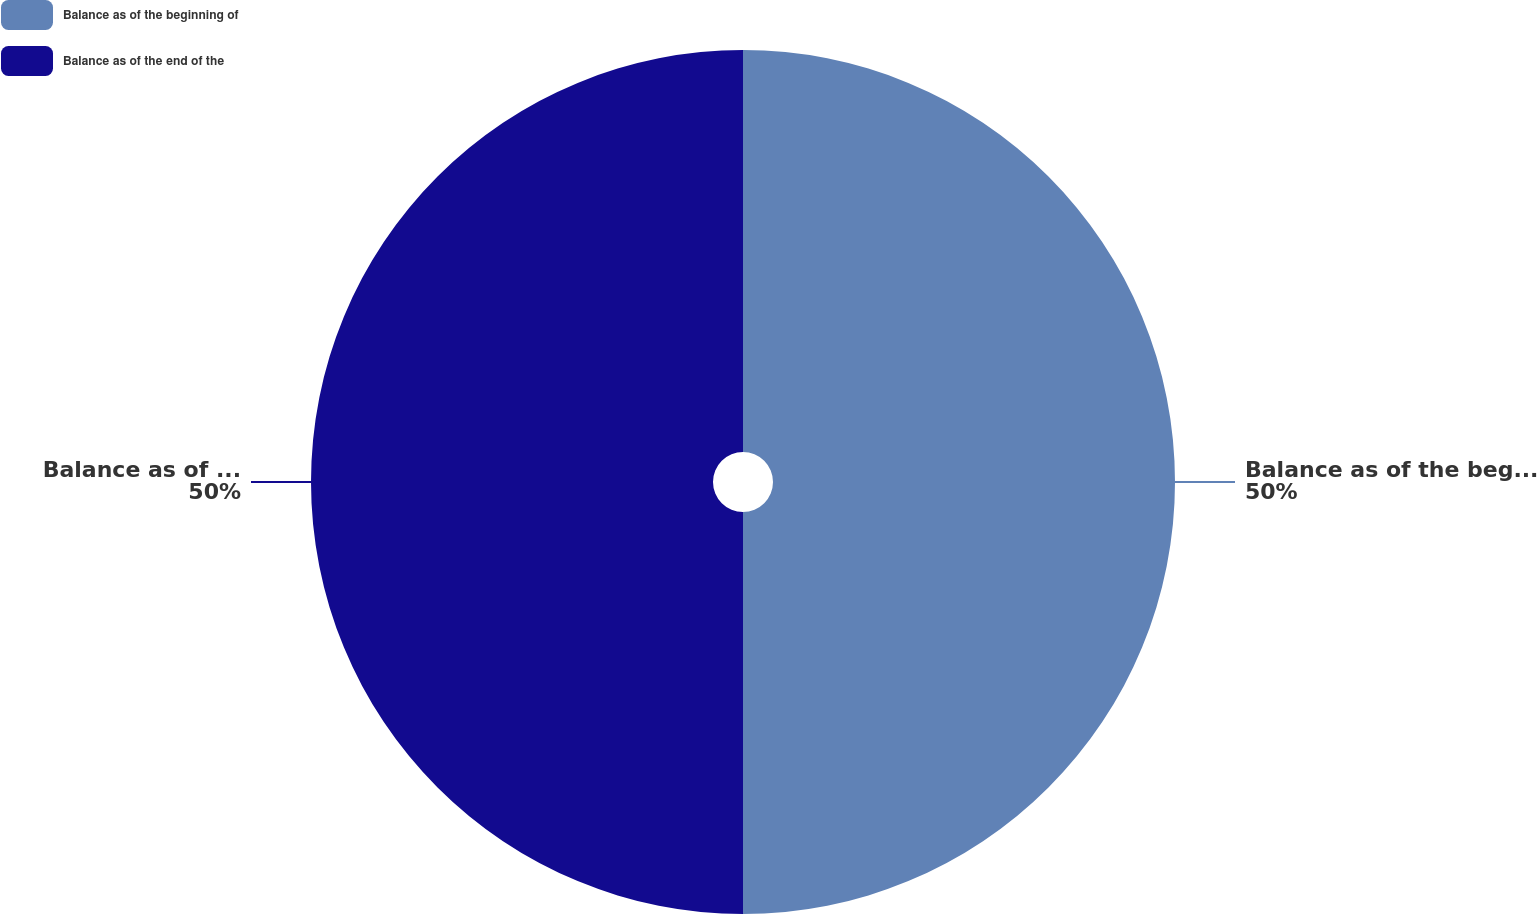Convert chart to OTSL. <chart><loc_0><loc_0><loc_500><loc_500><pie_chart><fcel>Balance as of the beginning of<fcel>Balance as of the end of the<nl><fcel>50.0%<fcel>50.0%<nl></chart> 